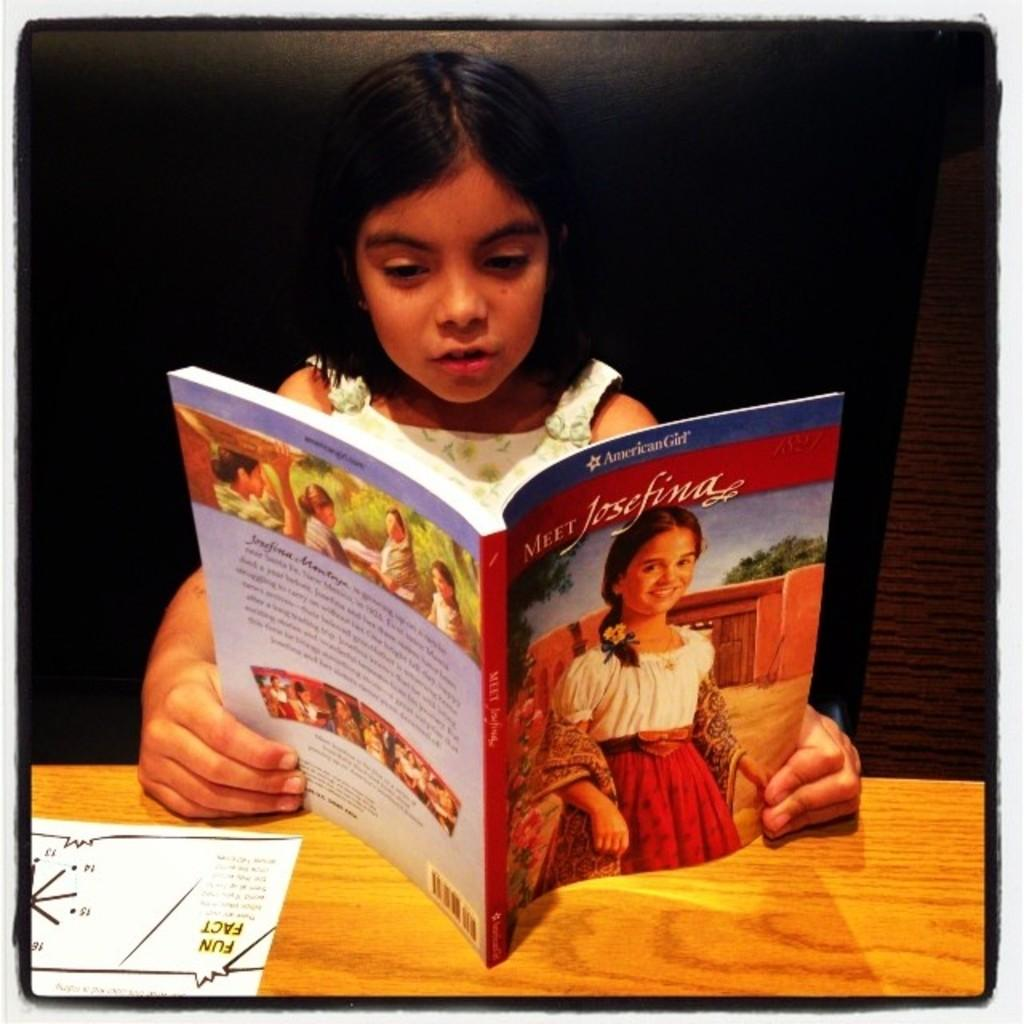<image>
Offer a succinct explanation of the picture presented. The little girl is reading a storybook name "Meet Josefina". 